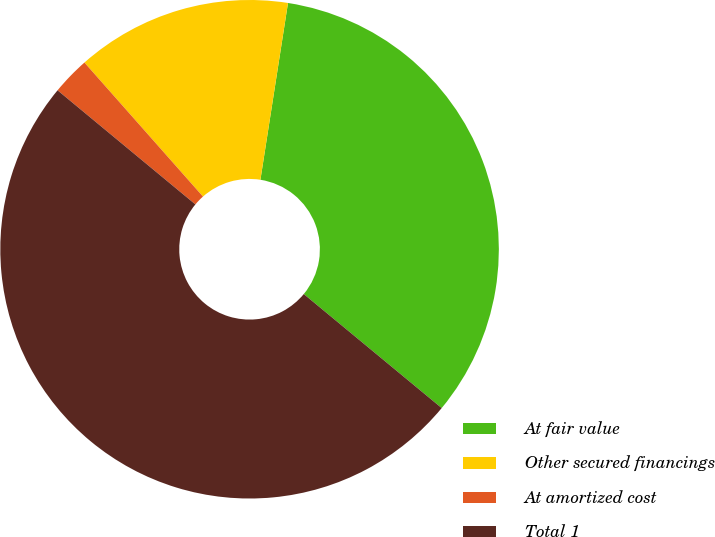<chart> <loc_0><loc_0><loc_500><loc_500><pie_chart><fcel>At fair value<fcel>Other secured financings<fcel>At amortized cost<fcel>Total 1<nl><fcel>33.53%<fcel>13.99%<fcel>2.47%<fcel>50.01%<nl></chart> 